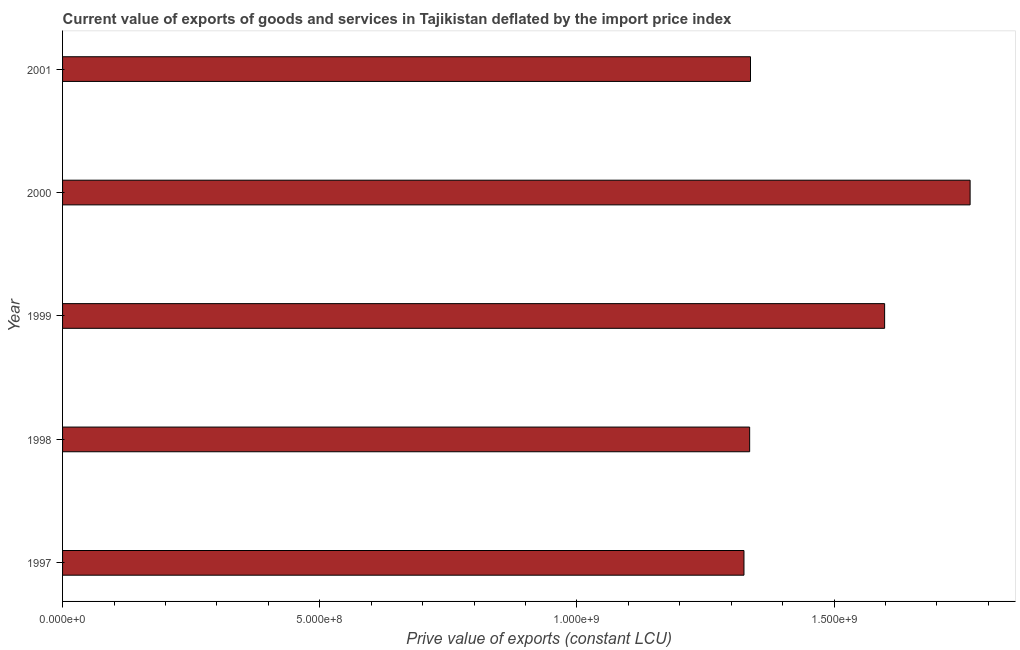Does the graph contain any zero values?
Offer a very short reply. No. What is the title of the graph?
Your answer should be very brief. Current value of exports of goods and services in Tajikistan deflated by the import price index. What is the label or title of the X-axis?
Make the answer very short. Prive value of exports (constant LCU). What is the price value of exports in 2001?
Offer a very short reply. 1.34e+09. Across all years, what is the maximum price value of exports?
Keep it short and to the point. 1.76e+09. Across all years, what is the minimum price value of exports?
Your answer should be compact. 1.32e+09. What is the sum of the price value of exports?
Make the answer very short. 7.36e+09. What is the difference between the price value of exports in 1997 and 1998?
Your response must be concise. -1.11e+07. What is the average price value of exports per year?
Provide a succinct answer. 1.47e+09. What is the median price value of exports?
Provide a succinct answer. 1.34e+09. In how many years, is the price value of exports greater than 1300000000 LCU?
Keep it short and to the point. 5. What is the ratio of the price value of exports in 1997 to that in 2001?
Provide a short and direct response. 0.99. Is the price value of exports in 1998 less than that in 1999?
Keep it short and to the point. Yes. What is the difference between the highest and the second highest price value of exports?
Provide a short and direct response. 1.66e+08. Is the sum of the price value of exports in 1999 and 2000 greater than the maximum price value of exports across all years?
Your answer should be very brief. Yes. What is the difference between the highest and the lowest price value of exports?
Offer a very short reply. 4.40e+08. In how many years, is the price value of exports greater than the average price value of exports taken over all years?
Keep it short and to the point. 2. Are all the bars in the graph horizontal?
Your response must be concise. Yes. How many years are there in the graph?
Make the answer very short. 5. Are the values on the major ticks of X-axis written in scientific E-notation?
Provide a succinct answer. Yes. What is the Prive value of exports (constant LCU) in 1997?
Provide a short and direct response. 1.32e+09. What is the Prive value of exports (constant LCU) of 1998?
Your response must be concise. 1.34e+09. What is the Prive value of exports (constant LCU) in 1999?
Give a very brief answer. 1.60e+09. What is the Prive value of exports (constant LCU) of 2000?
Give a very brief answer. 1.76e+09. What is the Prive value of exports (constant LCU) in 2001?
Your answer should be very brief. 1.34e+09. What is the difference between the Prive value of exports (constant LCU) in 1997 and 1998?
Give a very brief answer. -1.11e+07. What is the difference between the Prive value of exports (constant LCU) in 1997 and 1999?
Ensure brevity in your answer.  -2.73e+08. What is the difference between the Prive value of exports (constant LCU) in 1997 and 2000?
Ensure brevity in your answer.  -4.40e+08. What is the difference between the Prive value of exports (constant LCU) in 1997 and 2001?
Provide a short and direct response. -1.27e+07. What is the difference between the Prive value of exports (constant LCU) in 1998 and 1999?
Keep it short and to the point. -2.62e+08. What is the difference between the Prive value of exports (constant LCU) in 1998 and 2000?
Give a very brief answer. -4.29e+08. What is the difference between the Prive value of exports (constant LCU) in 1998 and 2001?
Your answer should be compact. -1.64e+06. What is the difference between the Prive value of exports (constant LCU) in 1999 and 2000?
Your response must be concise. -1.66e+08. What is the difference between the Prive value of exports (constant LCU) in 1999 and 2001?
Ensure brevity in your answer.  2.61e+08. What is the difference between the Prive value of exports (constant LCU) in 2000 and 2001?
Offer a terse response. 4.27e+08. What is the ratio of the Prive value of exports (constant LCU) in 1997 to that in 1999?
Give a very brief answer. 0.83. What is the ratio of the Prive value of exports (constant LCU) in 1997 to that in 2000?
Make the answer very short. 0.75. What is the ratio of the Prive value of exports (constant LCU) in 1998 to that in 1999?
Your answer should be compact. 0.84. What is the ratio of the Prive value of exports (constant LCU) in 1998 to that in 2000?
Give a very brief answer. 0.76. What is the ratio of the Prive value of exports (constant LCU) in 1998 to that in 2001?
Ensure brevity in your answer.  1. What is the ratio of the Prive value of exports (constant LCU) in 1999 to that in 2000?
Ensure brevity in your answer.  0.91. What is the ratio of the Prive value of exports (constant LCU) in 1999 to that in 2001?
Your response must be concise. 1.2. What is the ratio of the Prive value of exports (constant LCU) in 2000 to that in 2001?
Offer a terse response. 1.32. 